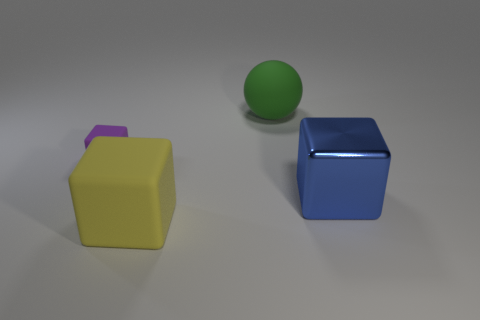Add 4 big green spheres. How many objects exist? 8 Subtract all blue metallic blocks. How many blocks are left? 2 Subtract 2 cubes. How many cubes are left? 1 Add 2 green objects. How many green objects are left? 3 Add 1 blue metal things. How many blue metal things exist? 2 Subtract all blue cubes. How many cubes are left? 2 Subtract 1 blue blocks. How many objects are left? 3 Subtract all spheres. How many objects are left? 3 Subtract all brown cubes. Subtract all blue balls. How many cubes are left? 3 Subtract all cyan spheres. How many purple cubes are left? 1 